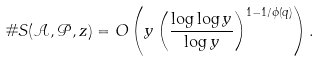Convert formula to latex. <formula><loc_0><loc_0><loc_500><loc_500>\# S ( \mathcal { A } , \mathcal { P } , z ) = O \left ( y \left ( \frac { \log \log y } { \log y } \right ) ^ { 1 - 1 / \phi ( q ) } \right ) .</formula> 